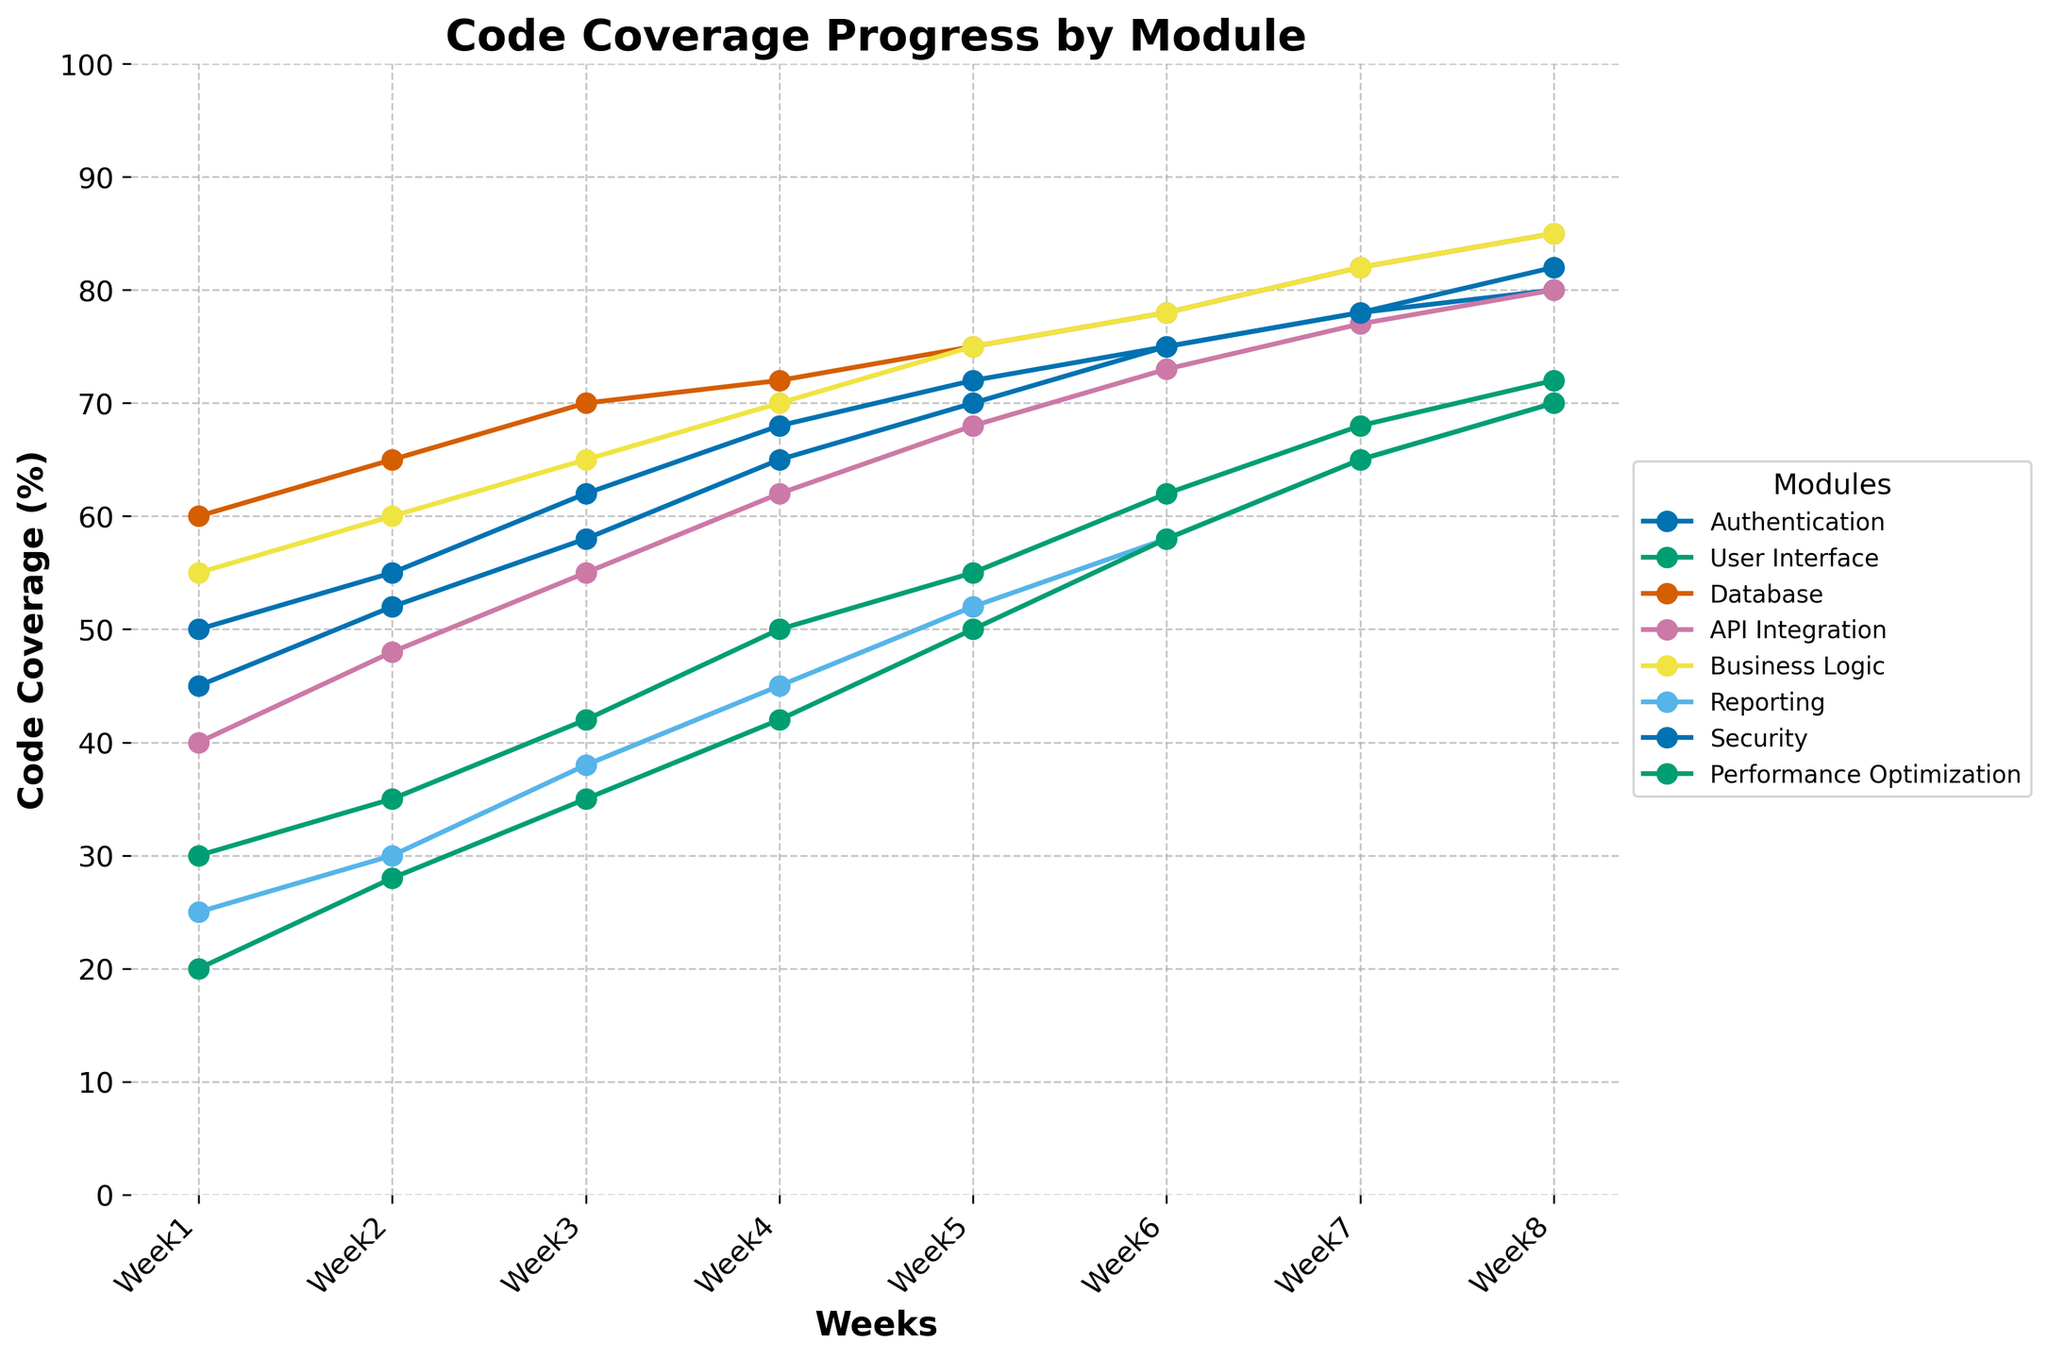What's the code coverage percentage for the Authentication module in Week 5? To find this, look for the line representing the Authentication module and pinpoint its value at Week 5.
Answer: 70 Which module had the highest code coverage percentage in Week 1 and what was that percentage? Identify the line with the highest value at the Week 1 marker among all the modules.
Answer: Database, 60 By how much did the code coverage percentage of the User Interface module increase from Week 1 to Week 8? Find the values of code coverage for the User Interface module at Week 1 and Week 8, then subtract the Week 1 value from the Week 8 value.
Answer: 42 Which two modules had the same code coverage percentage in Week 8, and what was that percentage? Compare the code coverage percentages of all modules at Week 8 and find those with the same value.
Answer: Business Logic and Database, 85 What is the overall trend of the code coverage percentage for the Performance Optimization module? Observe the direction of the line representing the Performance Optimization module from Week 1 to Week 8.
Answer: Increasing Which module showed the most significant improvement in code coverage percentage between Week 4 and Week 5? Calculate the difference in code coverage percentages between Week 4 and Week 5 for each module and identify the largest value.
Answer: Performance Optimization Did any module’s code coverage percentage exceed 80% before Week 8? Review the line chart to find if any module line crosses the 80% mark before Week 8.
Answer: No How would you describe the code coverage growth of the API Integration module over the eight weeks? Look at the slope and progression of the line representing the API Integration module over time.
Answer: Gradual and steady 